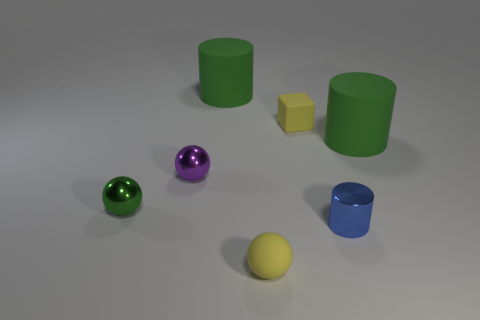Does the large rubber object that is to the left of the small yellow matte ball have the same color as the tiny metal ball in front of the purple shiny thing?
Provide a short and direct response. Yes. What number of other objects are there of the same color as the small cylinder?
Give a very brief answer. 0. Is the size of the green matte cylinder that is left of the small metal cylinder the same as the metallic thing to the right of the purple shiny ball?
Your answer should be compact. No. Are there an equal number of yellow rubber balls behind the yellow block and tiny matte blocks behind the small yellow matte sphere?
Offer a terse response. No. There is a metal cylinder; is it the same size as the yellow matte thing that is in front of the small green metallic ball?
Offer a terse response. Yes. What is the material of the sphere in front of the metal object that is left of the purple thing?
Make the answer very short. Rubber. Is the number of tiny cylinders that are on the left side of the blue cylinder the same as the number of brown metal objects?
Provide a short and direct response. Yes. What is the size of the metallic object that is in front of the purple shiny ball and on the left side of the blue thing?
Offer a very short reply. Small. There is a tiny rubber sphere that is in front of the big green matte cylinder that is on the left side of the matte cube; what color is it?
Offer a terse response. Yellow. What number of gray objects are big cylinders or tiny metallic objects?
Your answer should be very brief. 0. 